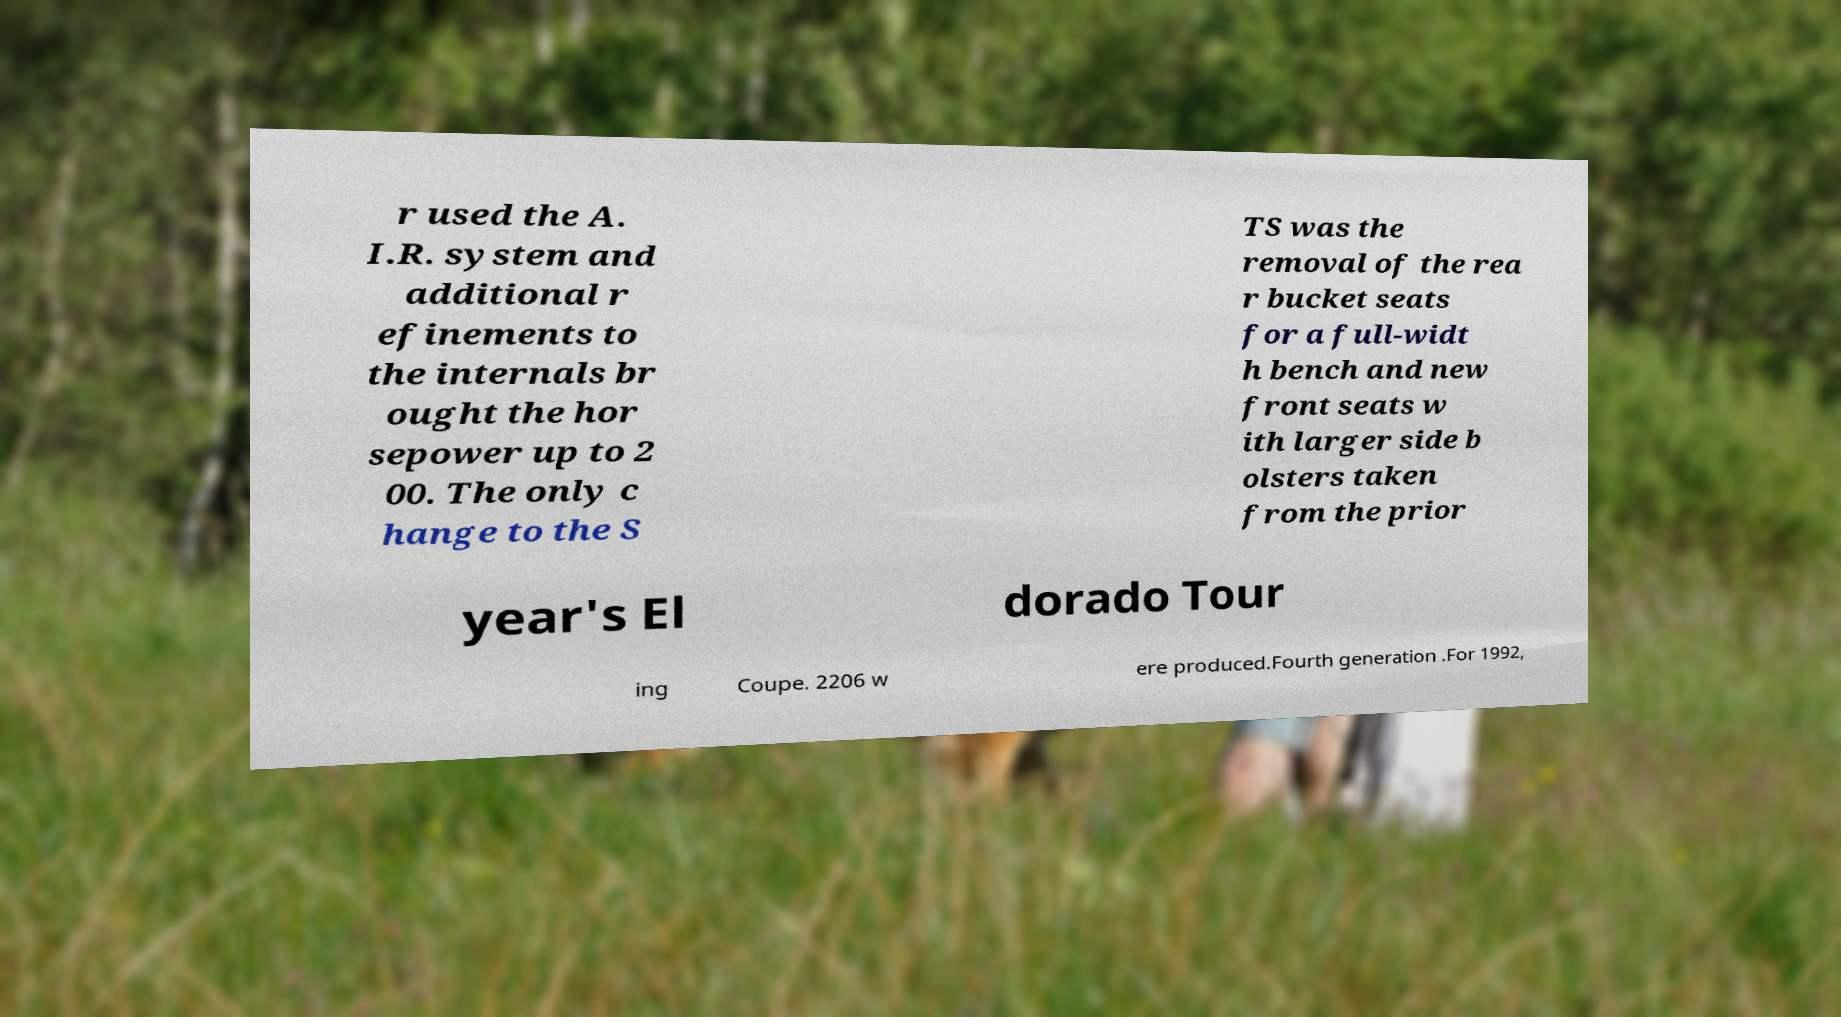Can you read and provide the text displayed in the image?This photo seems to have some interesting text. Can you extract and type it out for me? r used the A. I.R. system and additional r efinements to the internals br ought the hor sepower up to 2 00. The only c hange to the S TS was the removal of the rea r bucket seats for a full-widt h bench and new front seats w ith larger side b olsters taken from the prior year's El dorado Tour ing Coupe. 2206 w ere produced.Fourth generation .For 1992, 